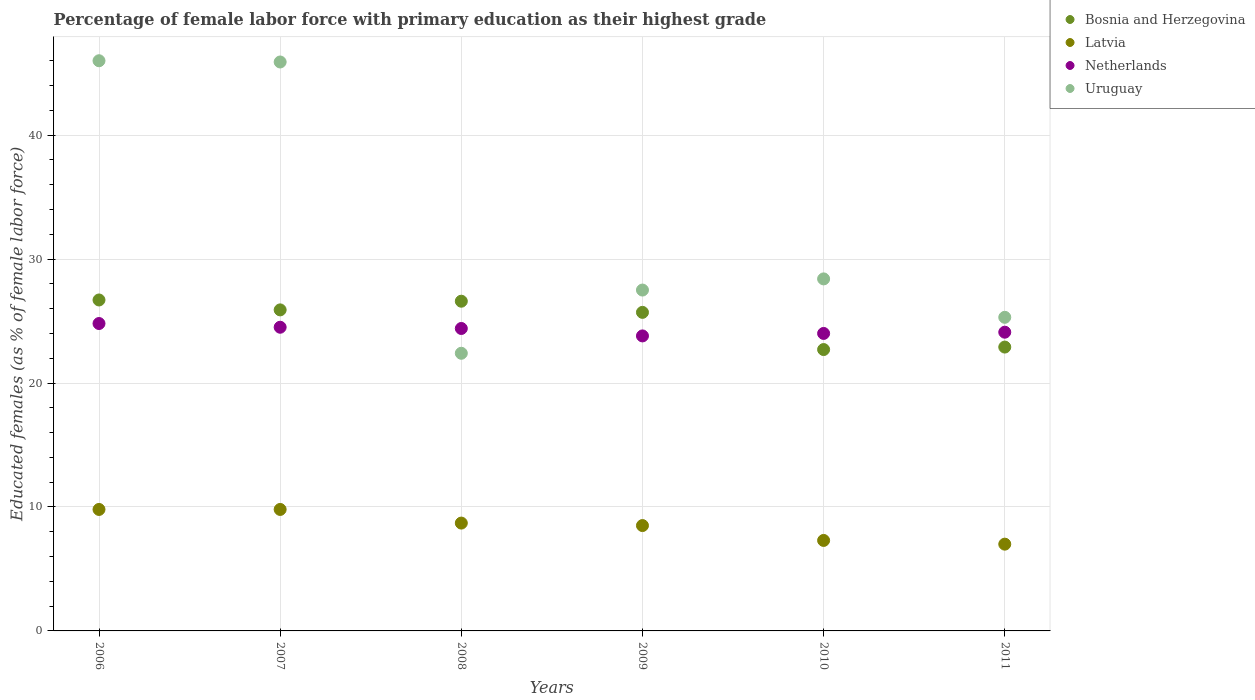Is the number of dotlines equal to the number of legend labels?
Keep it short and to the point. Yes. What is the percentage of female labor force with primary education in Uruguay in 2011?
Offer a very short reply. 25.3. In which year was the percentage of female labor force with primary education in Netherlands minimum?
Provide a succinct answer. 2009. What is the total percentage of female labor force with primary education in Netherlands in the graph?
Your response must be concise. 145.6. What is the difference between the percentage of female labor force with primary education in Latvia in 2006 and that in 2008?
Your response must be concise. 1.1. What is the difference between the percentage of female labor force with primary education in Bosnia and Herzegovina in 2006 and the percentage of female labor force with primary education in Latvia in 2010?
Make the answer very short. 19.4. What is the average percentage of female labor force with primary education in Netherlands per year?
Ensure brevity in your answer.  24.27. In the year 2010, what is the difference between the percentage of female labor force with primary education in Latvia and percentage of female labor force with primary education in Uruguay?
Keep it short and to the point. -21.1. In how many years, is the percentage of female labor force with primary education in Latvia greater than 40 %?
Your response must be concise. 0. What is the ratio of the percentage of female labor force with primary education in Latvia in 2006 to that in 2008?
Provide a succinct answer. 1.13. What is the difference between the highest and the second highest percentage of female labor force with primary education in Bosnia and Herzegovina?
Your answer should be very brief. 0.1. Is the percentage of female labor force with primary education in Uruguay strictly greater than the percentage of female labor force with primary education in Latvia over the years?
Your response must be concise. Yes. Does the graph contain any zero values?
Make the answer very short. No. What is the title of the graph?
Give a very brief answer. Percentage of female labor force with primary education as their highest grade. Does "Pacific island small states" appear as one of the legend labels in the graph?
Make the answer very short. No. What is the label or title of the X-axis?
Provide a short and direct response. Years. What is the label or title of the Y-axis?
Provide a short and direct response. Educated females (as % of female labor force). What is the Educated females (as % of female labor force) in Bosnia and Herzegovina in 2006?
Provide a short and direct response. 26.7. What is the Educated females (as % of female labor force) in Latvia in 2006?
Offer a terse response. 9.8. What is the Educated females (as % of female labor force) of Netherlands in 2006?
Ensure brevity in your answer.  24.8. What is the Educated females (as % of female labor force) of Bosnia and Herzegovina in 2007?
Ensure brevity in your answer.  25.9. What is the Educated females (as % of female labor force) in Latvia in 2007?
Offer a terse response. 9.8. What is the Educated females (as % of female labor force) in Netherlands in 2007?
Provide a short and direct response. 24.5. What is the Educated females (as % of female labor force) in Uruguay in 2007?
Your answer should be compact. 45.9. What is the Educated females (as % of female labor force) of Bosnia and Herzegovina in 2008?
Provide a short and direct response. 26.6. What is the Educated females (as % of female labor force) in Latvia in 2008?
Give a very brief answer. 8.7. What is the Educated females (as % of female labor force) in Netherlands in 2008?
Offer a very short reply. 24.4. What is the Educated females (as % of female labor force) of Uruguay in 2008?
Ensure brevity in your answer.  22.4. What is the Educated females (as % of female labor force) of Bosnia and Herzegovina in 2009?
Offer a very short reply. 25.7. What is the Educated females (as % of female labor force) in Latvia in 2009?
Your answer should be compact. 8.5. What is the Educated females (as % of female labor force) in Netherlands in 2009?
Your response must be concise. 23.8. What is the Educated females (as % of female labor force) in Bosnia and Herzegovina in 2010?
Offer a very short reply. 22.7. What is the Educated females (as % of female labor force) in Latvia in 2010?
Keep it short and to the point. 7.3. What is the Educated females (as % of female labor force) of Uruguay in 2010?
Ensure brevity in your answer.  28.4. What is the Educated females (as % of female labor force) in Bosnia and Herzegovina in 2011?
Offer a terse response. 22.9. What is the Educated females (as % of female labor force) of Latvia in 2011?
Offer a terse response. 7. What is the Educated females (as % of female labor force) in Netherlands in 2011?
Your response must be concise. 24.1. What is the Educated females (as % of female labor force) in Uruguay in 2011?
Offer a very short reply. 25.3. Across all years, what is the maximum Educated females (as % of female labor force) of Bosnia and Herzegovina?
Your answer should be very brief. 26.7. Across all years, what is the maximum Educated females (as % of female labor force) in Latvia?
Your answer should be very brief. 9.8. Across all years, what is the maximum Educated females (as % of female labor force) in Netherlands?
Provide a short and direct response. 24.8. Across all years, what is the maximum Educated females (as % of female labor force) in Uruguay?
Offer a terse response. 46. Across all years, what is the minimum Educated females (as % of female labor force) of Bosnia and Herzegovina?
Keep it short and to the point. 22.7. Across all years, what is the minimum Educated females (as % of female labor force) in Netherlands?
Offer a very short reply. 23.8. Across all years, what is the minimum Educated females (as % of female labor force) of Uruguay?
Make the answer very short. 22.4. What is the total Educated females (as % of female labor force) of Bosnia and Herzegovina in the graph?
Keep it short and to the point. 150.5. What is the total Educated females (as % of female labor force) in Latvia in the graph?
Your response must be concise. 51.1. What is the total Educated females (as % of female labor force) in Netherlands in the graph?
Provide a short and direct response. 145.6. What is the total Educated females (as % of female labor force) of Uruguay in the graph?
Ensure brevity in your answer.  195.5. What is the difference between the Educated females (as % of female labor force) in Netherlands in 2006 and that in 2007?
Your answer should be very brief. 0.3. What is the difference between the Educated females (as % of female labor force) in Uruguay in 2006 and that in 2007?
Keep it short and to the point. 0.1. What is the difference between the Educated females (as % of female labor force) in Uruguay in 2006 and that in 2008?
Your answer should be very brief. 23.6. What is the difference between the Educated females (as % of female labor force) in Bosnia and Herzegovina in 2006 and that in 2009?
Make the answer very short. 1. What is the difference between the Educated females (as % of female labor force) in Latvia in 2006 and that in 2009?
Keep it short and to the point. 1.3. What is the difference between the Educated females (as % of female labor force) of Uruguay in 2006 and that in 2009?
Your answer should be very brief. 18.5. What is the difference between the Educated females (as % of female labor force) of Latvia in 2006 and that in 2010?
Your answer should be compact. 2.5. What is the difference between the Educated females (as % of female labor force) in Uruguay in 2006 and that in 2010?
Make the answer very short. 17.6. What is the difference between the Educated females (as % of female labor force) in Uruguay in 2006 and that in 2011?
Provide a short and direct response. 20.7. What is the difference between the Educated females (as % of female labor force) of Bosnia and Herzegovina in 2007 and that in 2008?
Provide a succinct answer. -0.7. What is the difference between the Educated females (as % of female labor force) in Netherlands in 2007 and that in 2008?
Give a very brief answer. 0.1. What is the difference between the Educated females (as % of female labor force) in Netherlands in 2007 and that in 2009?
Your response must be concise. 0.7. What is the difference between the Educated females (as % of female labor force) in Uruguay in 2007 and that in 2009?
Your answer should be very brief. 18.4. What is the difference between the Educated females (as % of female labor force) in Latvia in 2007 and that in 2010?
Your response must be concise. 2.5. What is the difference between the Educated females (as % of female labor force) of Netherlands in 2007 and that in 2010?
Your answer should be compact. 0.5. What is the difference between the Educated females (as % of female labor force) of Bosnia and Herzegovina in 2007 and that in 2011?
Your answer should be compact. 3. What is the difference between the Educated females (as % of female labor force) of Netherlands in 2007 and that in 2011?
Provide a succinct answer. 0.4. What is the difference between the Educated females (as % of female labor force) in Uruguay in 2007 and that in 2011?
Your answer should be compact. 20.6. What is the difference between the Educated females (as % of female labor force) of Netherlands in 2008 and that in 2009?
Provide a short and direct response. 0.6. What is the difference between the Educated females (as % of female labor force) in Uruguay in 2008 and that in 2009?
Offer a very short reply. -5.1. What is the difference between the Educated females (as % of female labor force) in Latvia in 2008 and that in 2010?
Ensure brevity in your answer.  1.4. What is the difference between the Educated females (as % of female labor force) in Netherlands in 2008 and that in 2010?
Offer a terse response. 0.4. What is the difference between the Educated females (as % of female labor force) of Netherlands in 2009 and that in 2010?
Keep it short and to the point. -0.2. What is the difference between the Educated females (as % of female labor force) of Uruguay in 2009 and that in 2011?
Provide a succinct answer. 2.2. What is the difference between the Educated females (as % of female labor force) in Netherlands in 2010 and that in 2011?
Provide a succinct answer. -0.1. What is the difference between the Educated females (as % of female labor force) of Bosnia and Herzegovina in 2006 and the Educated females (as % of female labor force) of Uruguay in 2007?
Your response must be concise. -19.2. What is the difference between the Educated females (as % of female labor force) of Latvia in 2006 and the Educated females (as % of female labor force) of Netherlands in 2007?
Your response must be concise. -14.7. What is the difference between the Educated females (as % of female labor force) of Latvia in 2006 and the Educated females (as % of female labor force) of Uruguay in 2007?
Make the answer very short. -36.1. What is the difference between the Educated females (as % of female labor force) of Netherlands in 2006 and the Educated females (as % of female labor force) of Uruguay in 2007?
Provide a succinct answer. -21.1. What is the difference between the Educated females (as % of female labor force) in Bosnia and Herzegovina in 2006 and the Educated females (as % of female labor force) in Netherlands in 2008?
Offer a terse response. 2.3. What is the difference between the Educated females (as % of female labor force) in Bosnia and Herzegovina in 2006 and the Educated females (as % of female labor force) in Uruguay in 2008?
Provide a succinct answer. 4.3. What is the difference between the Educated females (as % of female labor force) in Latvia in 2006 and the Educated females (as % of female labor force) in Netherlands in 2008?
Make the answer very short. -14.6. What is the difference between the Educated females (as % of female labor force) of Netherlands in 2006 and the Educated females (as % of female labor force) of Uruguay in 2008?
Offer a very short reply. 2.4. What is the difference between the Educated females (as % of female labor force) of Bosnia and Herzegovina in 2006 and the Educated females (as % of female labor force) of Latvia in 2009?
Your answer should be compact. 18.2. What is the difference between the Educated females (as % of female labor force) of Bosnia and Herzegovina in 2006 and the Educated females (as % of female labor force) of Netherlands in 2009?
Offer a very short reply. 2.9. What is the difference between the Educated females (as % of female labor force) in Bosnia and Herzegovina in 2006 and the Educated females (as % of female labor force) in Uruguay in 2009?
Your response must be concise. -0.8. What is the difference between the Educated females (as % of female labor force) in Latvia in 2006 and the Educated females (as % of female labor force) in Netherlands in 2009?
Your response must be concise. -14. What is the difference between the Educated females (as % of female labor force) of Latvia in 2006 and the Educated females (as % of female labor force) of Uruguay in 2009?
Provide a succinct answer. -17.7. What is the difference between the Educated females (as % of female labor force) in Netherlands in 2006 and the Educated females (as % of female labor force) in Uruguay in 2009?
Provide a short and direct response. -2.7. What is the difference between the Educated females (as % of female labor force) in Bosnia and Herzegovina in 2006 and the Educated females (as % of female labor force) in Uruguay in 2010?
Offer a very short reply. -1.7. What is the difference between the Educated females (as % of female labor force) in Latvia in 2006 and the Educated females (as % of female labor force) in Uruguay in 2010?
Provide a succinct answer. -18.6. What is the difference between the Educated females (as % of female labor force) in Bosnia and Herzegovina in 2006 and the Educated females (as % of female labor force) in Latvia in 2011?
Your answer should be compact. 19.7. What is the difference between the Educated females (as % of female labor force) of Bosnia and Herzegovina in 2006 and the Educated females (as % of female labor force) of Netherlands in 2011?
Offer a very short reply. 2.6. What is the difference between the Educated females (as % of female labor force) of Bosnia and Herzegovina in 2006 and the Educated females (as % of female labor force) of Uruguay in 2011?
Keep it short and to the point. 1.4. What is the difference between the Educated females (as % of female labor force) of Latvia in 2006 and the Educated females (as % of female labor force) of Netherlands in 2011?
Make the answer very short. -14.3. What is the difference between the Educated females (as % of female labor force) of Latvia in 2006 and the Educated females (as % of female labor force) of Uruguay in 2011?
Keep it short and to the point. -15.5. What is the difference between the Educated females (as % of female labor force) in Bosnia and Herzegovina in 2007 and the Educated females (as % of female labor force) in Netherlands in 2008?
Ensure brevity in your answer.  1.5. What is the difference between the Educated females (as % of female labor force) in Latvia in 2007 and the Educated females (as % of female labor force) in Netherlands in 2008?
Your response must be concise. -14.6. What is the difference between the Educated females (as % of female labor force) in Latvia in 2007 and the Educated females (as % of female labor force) in Uruguay in 2008?
Keep it short and to the point. -12.6. What is the difference between the Educated females (as % of female labor force) of Bosnia and Herzegovina in 2007 and the Educated females (as % of female labor force) of Netherlands in 2009?
Keep it short and to the point. 2.1. What is the difference between the Educated females (as % of female labor force) of Latvia in 2007 and the Educated females (as % of female labor force) of Netherlands in 2009?
Your response must be concise. -14. What is the difference between the Educated females (as % of female labor force) in Latvia in 2007 and the Educated females (as % of female labor force) in Uruguay in 2009?
Ensure brevity in your answer.  -17.7. What is the difference between the Educated females (as % of female labor force) in Bosnia and Herzegovina in 2007 and the Educated females (as % of female labor force) in Netherlands in 2010?
Ensure brevity in your answer.  1.9. What is the difference between the Educated females (as % of female labor force) in Latvia in 2007 and the Educated females (as % of female labor force) in Netherlands in 2010?
Your answer should be very brief. -14.2. What is the difference between the Educated females (as % of female labor force) of Latvia in 2007 and the Educated females (as % of female labor force) of Uruguay in 2010?
Your answer should be compact. -18.6. What is the difference between the Educated females (as % of female labor force) in Netherlands in 2007 and the Educated females (as % of female labor force) in Uruguay in 2010?
Offer a very short reply. -3.9. What is the difference between the Educated females (as % of female labor force) of Bosnia and Herzegovina in 2007 and the Educated females (as % of female labor force) of Latvia in 2011?
Offer a terse response. 18.9. What is the difference between the Educated females (as % of female labor force) of Bosnia and Herzegovina in 2007 and the Educated females (as % of female labor force) of Netherlands in 2011?
Your response must be concise. 1.8. What is the difference between the Educated females (as % of female labor force) in Bosnia and Herzegovina in 2007 and the Educated females (as % of female labor force) in Uruguay in 2011?
Provide a succinct answer. 0.6. What is the difference between the Educated females (as % of female labor force) of Latvia in 2007 and the Educated females (as % of female labor force) of Netherlands in 2011?
Offer a very short reply. -14.3. What is the difference between the Educated females (as % of female labor force) of Latvia in 2007 and the Educated females (as % of female labor force) of Uruguay in 2011?
Provide a succinct answer. -15.5. What is the difference between the Educated females (as % of female labor force) in Netherlands in 2007 and the Educated females (as % of female labor force) in Uruguay in 2011?
Give a very brief answer. -0.8. What is the difference between the Educated females (as % of female labor force) in Bosnia and Herzegovina in 2008 and the Educated females (as % of female labor force) in Latvia in 2009?
Your response must be concise. 18.1. What is the difference between the Educated females (as % of female labor force) of Bosnia and Herzegovina in 2008 and the Educated females (as % of female labor force) of Netherlands in 2009?
Give a very brief answer. 2.8. What is the difference between the Educated females (as % of female labor force) of Bosnia and Herzegovina in 2008 and the Educated females (as % of female labor force) of Uruguay in 2009?
Make the answer very short. -0.9. What is the difference between the Educated females (as % of female labor force) in Latvia in 2008 and the Educated females (as % of female labor force) in Netherlands in 2009?
Offer a very short reply. -15.1. What is the difference between the Educated females (as % of female labor force) in Latvia in 2008 and the Educated females (as % of female labor force) in Uruguay in 2009?
Make the answer very short. -18.8. What is the difference between the Educated females (as % of female labor force) in Netherlands in 2008 and the Educated females (as % of female labor force) in Uruguay in 2009?
Your answer should be very brief. -3.1. What is the difference between the Educated females (as % of female labor force) in Bosnia and Herzegovina in 2008 and the Educated females (as % of female labor force) in Latvia in 2010?
Provide a short and direct response. 19.3. What is the difference between the Educated females (as % of female labor force) of Bosnia and Herzegovina in 2008 and the Educated females (as % of female labor force) of Netherlands in 2010?
Keep it short and to the point. 2.6. What is the difference between the Educated females (as % of female labor force) in Bosnia and Herzegovina in 2008 and the Educated females (as % of female labor force) in Uruguay in 2010?
Offer a very short reply. -1.8. What is the difference between the Educated females (as % of female labor force) in Latvia in 2008 and the Educated females (as % of female labor force) in Netherlands in 2010?
Your response must be concise. -15.3. What is the difference between the Educated females (as % of female labor force) in Latvia in 2008 and the Educated females (as % of female labor force) in Uruguay in 2010?
Provide a short and direct response. -19.7. What is the difference between the Educated females (as % of female labor force) in Bosnia and Herzegovina in 2008 and the Educated females (as % of female labor force) in Latvia in 2011?
Offer a terse response. 19.6. What is the difference between the Educated females (as % of female labor force) in Bosnia and Herzegovina in 2008 and the Educated females (as % of female labor force) in Netherlands in 2011?
Provide a short and direct response. 2.5. What is the difference between the Educated females (as % of female labor force) of Latvia in 2008 and the Educated females (as % of female labor force) of Netherlands in 2011?
Offer a terse response. -15.4. What is the difference between the Educated females (as % of female labor force) in Latvia in 2008 and the Educated females (as % of female labor force) in Uruguay in 2011?
Provide a short and direct response. -16.6. What is the difference between the Educated females (as % of female labor force) of Netherlands in 2008 and the Educated females (as % of female labor force) of Uruguay in 2011?
Provide a short and direct response. -0.9. What is the difference between the Educated females (as % of female labor force) in Bosnia and Herzegovina in 2009 and the Educated females (as % of female labor force) in Latvia in 2010?
Keep it short and to the point. 18.4. What is the difference between the Educated females (as % of female labor force) in Latvia in 2009 and the Educated females (as % of female labor force) in Netherlands in 2010?
Offer a very short reply. -15.5. What is the difference between the Educated females (as % of female labor force) of Latvia in 2009 and the Educated females (as % of female labor force) of Uruguay in 2010?
Provide a short and direct response. -19.9. What is the difference between the Educated females (as % of female labor force) in Bosnia and Herzegovina in 2009 and the Educated females (as % of female labor force) in Latvia in 2011?
Keep it short and to the point. 18.7. What is the difference between the Educated females (as % of female labor force) of Bosnia and Herzegovina in 2009 and the Educated females (as % of female labor force) of Uruguay in 2011?
Ensure brevity in your answer.  0.4. What is the difference between the Educated females (as % of female labor force) in Latvia in 2009 and the Educated females (as % of female labor force) in Netherlands in 2011?
Provide a succinct answer. -15.6. What is the difference between the Educated females (as % of female labor force) in Latvia in 2009 and the Educated females (as % of female labor force) in Uruguay in 2011?
Offer a terse response. -16.8. What is the difference between the Educated females (as % of female labor force) in Bosnia and Herzegovina in 2010 and the Educated females (as % of female labor force) in Uruguay in 2011?
Provide a short and direct response. -2.6. What is the difference between the Educated females (as % of female labor force) of Latvia in 2010 and the Educated females (as % of female labor force) of Netherlands in 2011?
Offer a terse response. -16.8. What is the difference between the Educated females (as % of female labor force) of Latvia in 2010 and the Educated females (as % of female labor force) of Uruguay in 2011?
Offer a very short reply. -18. What is the average Educated females (as % of female labor force) of Bosnia and Herzegovina per year?
Your response must be concise. 25.08. What is the average Educated females (as % of female labor force) of Latvia per year?
Offer a terse response. 8.52. What is the average Educated females (as % of female labor force) of Netherlands per year?
Ensure brevity in your answer.  24.27. What is the average Educated females (as % of female labor force) in Uruguay per year?
Your response must be concise. 32.58. In the year 2006, what is the difference between the Educated females (as % of female labor force) in Bosnia and Herzegovina and Educated females (as % of female labor force) in Uruguay?
Ensure brevity in your answer.  -19.3. In the year 2006, what is the difference between the Educated females (as % of female labor force) in Latvia and Educated females (as % of female labor force) in Netherlands?
Offer a very short reply. -15. In the year 2006, what is the difference between the Educated females (as % of female labor force) of Latvia and Educated females (as % of female labor force) of Uruguay?
Your answer should be very brief. -36.2. In the year 2006, what is the difference between the Educated females (as % of female labor force) of Netherlands and Educated females (as % of female labor force) of Uruguay?
Your response must be concise. -21.2. In the year 2007, what is the difference between the Educated females (as % of female labor force) in Bosnia and Herzegovina and Educated females (as % of female labor force) in Uruguay?
Ensure brevity in your answer.  -20. In the year 2007, what is the difference between the Educated females (as % of female labor force) in Latvia and Educated females (as % of female labor force) in Netherlands?
Provide a short and direct response. -14.7. In the year 2007, what is the difference between the Educated females (as % of female labor force) in Latvia and Educated females (as % of female labor force) in Uruguay?
Give a very brief answer. -36.1. In the year 2007, what is the difference between the Educated females (as % of female labor force) in Netherlands and Educated females (as % of female labor force) in Uruguay?
Offer a terse response. -21.4. In the year 2008, what is the difference between the Educated females (as % of female labor force) of Bosnia and Herzegovina and Educated females (as % of female labor force) of Latvia?
Your answer should be compact. 17.9. In the year 2008, what is the difference between the Educated females (as % of female labor force) in Latvia and Educated females (as % of female labor force) in Netherlands?
Your answer should be very brief. -15.7. In the year 2008, what is the difference between the Educated females (as % of female labor force) of Latvia and Educated females (as % of female labor force) of Uruguay?
Keep it short and to the point. -13.7. In the year 2009, what is the difference between the Educated females (as % of female labor force) of Bosnia and Herzegovina and Educated females (as % of female labor force) of Uruguay?
Give a very brief answer. -1.8. In the year 2009, what is the difference between the Educated females (as % of female labor force) of Latvia and Educated females (as % of female labor force) of Netherlands?
Your answer should be compact. -15.3. In the year 2010, what is the difference between the Educated females (as % of female labor force) of Bosnia and Herzegovina and Educated females (as % of female labor force) of Latvia?
Ensure brevity in your answer.  15.4. In the year 2010, what is the difference between the Educated females (as % of female labor force) in Bosnia and Herzegovina and Educated females (as % of female labor force) in Netherlands?
Keep it short and to the point. -1.3. In the year 2010, what is the difference between the Educated females (as % of female labor force) of Latvia and Educated females (as % of female labor force) of Netherlands?
Your answer should be very brief. -16.7. In the year 2010, what is the difference between the Educated females (as % of female labor force) in Latvia and Educated females (as % of female labor force) in Uruguay?
Your answer should be compact. -21.1. In the year 2011, what is the difference between the Educated females (as % of female labor force) in Bosnia and Herzegovina and Educated females (as % of female labor force) in Latvia?
Provide a short and direct response. 15.9. In the year 2011, what is the difference between the Educated females (as % of female labor force) of Bosnia and Herzegovina and Educated females (as % of female labor force) of Uruguay?
Give a very brief answer. -2.4. In the year 2011, what is the difference between the Educated females (as % of female labor force) in Latvia and Educated females (as % of female labor force) in Netherlands?
Your answer should be compact. -17.1. In the year 2011, what is the difference between the Educated females (as % of female labor force) in Latvia and Educated females (as % of female labor force) in Uruguay?
Your response must be concise. -18.3. In the year 2011, what is the difference between the Educated females (as % of female labor force) in Netherlands and Educated females (as % of female labor force) in Uruguay?
Your answer should be very brief. -1.2. What is the ratio of the Educated females (as % of female labor force) of Bosnia and Herzegovina in 2006 to that in 2007?
Provide a succinct answer. 1.03. What is the ratio of the Educated females (as % of female labor force) in Latvia in 2006 to that in 2007?
Offer a very short reply. 1. What is the ratio of the Educated females (as % of female labor force) in Netherlands in 2006 to that in 2007?
Provide a short and direct response. 1.01. What is the ratio of the Educated females (as % of female labor force) of Latvia in 2006 to that in 2008?
Keep it short and to the point. 1.13. What is the ratio of the Educated females (as % of female labor force) of Netherlands in 2006 to that in 2008?
Your response must be concise. 1.02. What is the ratio of the Educated females (as % of female labor force) in Uruguay in 2006 to that in 2008?
Offer a terse response. 2.05. What is the ratio of the Educated females (as % of female labor force) of Bosnia and Herzegovina in 2006 to that in 2009?
Make the answer very short. 1.04. What is the ratio of the Educated females (as % of female labor force) of Latvia in 2006 to that in 2009?
Offer a terse response. 1.15. What is the ratio of the Educated females (as % of female labor force) of Netherlands in 2006 to that in 2009?
Provide a short and direct response. 1.04. What is the ratio of the Educated females (as % of female labor force) of Uruguay in 2006 to that in 2009?
Your response must be concise. 1.67. What is the ratio of the Educated females (as % of female labor force) in Bosnia and Herzegovina in 2006 to that in 2010?
Ensure brevity in your answer.  1.18. What is the ratio of the Educated females (as % of female labor force) in Latvia in 2006 to that in 2010?
Your answer should be very brief. 1.34. What is the ratio of the Educated females (as % of female labor force) in Uruguay in 2006 to that in 2010?
Offer a terse response. 1.62. What is the ratio of the Educated females (as % of female labor force) in Bosnia and Herzegovina in 2006 to that in 2011?
Your answer should be very brief. 1.17. What is the ratio of the Educated females (as % of female labor force) of Latvia in 2006 to that in 2011?
Keep it short and to the point. 1.4. What is the ratio of the Educated females (as % of female labor force) in Uruguay in 2006 to that in 2011?
Your answer should be very brief. 1.82. What is the ratio of the Educated females (as % of female labor force) of Bosnia and Herzegovina in 2007 to that in 2008?
Make the answer very short. 0.97. What is the ratio of the Educated females (as % of female labor force) in Latvia in 2007 to that in 2008?
Your response must be concise. 1.13. What is the ratio of the Educated females (as % of female labor force) in Netherlands in 2007 to that in 2008?
Your response must be concise. 1. What is the ratio of the Educated females (as % of female labor force) in Uruguay in 2007 to that in 2008?
Your response must be concise. 2.05. What is the ratio of the Educated females (as % of female labor force) of Bosnia and Herzegovina in 2007 to that in 2009?
Offer a very short reply. 1.01. What is the ratio of the Educated females (as % of female labor force) in Latvia in 2007 to that in 2009?
Make the answer very short. 1.15. What is the ratio of the Educated females (as % of female labor force) in Netherlands in 2007 to that in 2009?
Keep it short and to the point. 1.03. What is the ratio of the Educated females (as % of female labor force) in Uruguay in 2007 to that in 2009?
Offer a very short reply. 1.67. What is the ratio of the Educated females (as % of female labor force) of Bosnia and Herzegovina in 2007 to that in 2010?
Keep it short and to the point. 1.14. What is the ratio of the Educated females (as % of female labor force) in Latvia in 2007 to that in 2010?
Provide a short and direct response. 1.34. What is the ratio of the Educated females (as % of female labor force) in Netherlands in 2007 to that in 2010?
Provide a short and direct response. 1.02. What is the ratio of the Educated females (as % of female labor force) in Uruguay in 2007 to that in 2010?
Keep it short and to the point. 1.62. What is the ratio of the Educated females (as % of female labor force) in Bosnia and Herzegovina in 2007 to that in 2011?
Ensure brevity in your answer.  1.13. What is the ratio of the Educated females (as % of female labor force) of Latvia in 2007 to that in 2011?
Provide a short and direct response. 1.4. What is the ratio of the Educated females (as % of female labor force) in Netherlands in 2007 to that in 2011?
Your answer should be compact. 1.02. What is the ratio of the Educated females (as % of female labor force) in Uruguay in 2007 to that in 2011?
Your response must be concise. 1.81. What is the ratio of the Educated females (as % of female labor force) of Bosnia and Herzegovina in 2008 to that in 2009?
Your response must be concise. 1.03. What is the ratio of the Educated females (as % of female labor force) in Latvia in 2008 to that in 2009?
Your response must be concise. 1.02. What is the ratio of the Educated females (as % of female labor force) of Netherlands in 2008 to that in 2009?
Your answer should be compact. 1.03. What is the ratio of the Educated females (as % of female labor force) of Uruguay in 2008 to that in 2009?
Offer a terse response. 0.81. What is the ratio of the Educated females (as % of female labor force) of Bosnia and Herzegovina in 2008 to that in 2010?
Offer a very short reply. 1.17. What is the ratio of the Educated females (as % of female labor force) in Latvia in 2008 to that in 2010?
Your answer should be compact. 1.19. What is the ratio of the Educated females (as % of female labor force) of Netherlands in 2008 to that in 2010?
Make the answer very short. 1.02. What is the ratio of the Educated females (as % of female labor force) in Uruguay in 2008 to that in 2010?
Your response must be concise. 0.79. What is the ratio of the Educated females (as % of female labor force) of Bosnia and Herzegovina in 2008 to that in 2011?
Ensure brevity in your answer.  1.16. What is the ratio of the Educated females (as % of female labor force) in Latvia in 2008 to that in 2011?
Make the answer very short. 1.24. What is the ratio of the Educated females (as % of female labor force) in Netherlands in 2008 to that in 2011?
Give a very brief answer. 1.01. What is the ratio of the Educated females (as % of female labor force) of Uruguay in 2008 to that in 2011?
Make the answer very short. 0.89. What is the ratio of the Educated females (as % of female labor force) in Bosnia and Herzegovina in 2009 to that in 2010?
Offer a very short reply. 1.13. What is the ratio of the Educated females (as % of female labor force) of Latvia in 2009 to that in 2010?
Your answer should be compact. 1.16. What is the ratio of the Educated females (as % of female labor force) of Netherlands in 2009 to that in 2010?
Make the answer very short. 0.99. What is the ratio of the Educated females (as % of female labor force) of Uruguay in 2009 to that in 2010?
Offer a terse response. 0.97. What is the ratio of the Educated females (as % of female labor force) of Bosnia and Herzegovina in 2009 to that in 2011?
Ensure brevity in your answer.  1.12. What is the ratio of the Educated females (as % of female labor force) of Latvia in 2009 to that in 2011?
Your response must be concise. 1.21. What is the ratio of the Educated females (as % of female labor force) of Netherlands in 2009 to that in 2011?
Ensure brevity in your answer.  0.99. What is the ratio of the Educated females (as % of female labor force) in Uruguay in 2009 to that in 2011?
Keep it short and to the point. 1.09. What is the ratio of the Educated females (as % of female labor force) in Latvia in 2010 to that in 2011?
Provide a succinct answer. 1.04. What is the ratio of the Educated females (as % of female labor force) in Uruguay in 2010 to that in 2011?
Your answer should be compact. 1.12. What is the difference between the highest and the second highest Educated females (as % of female labor force) in Netherlands?
Ensure brevity in your answer.  0.3. What is the difference between the highest and the lowest Educated females (as % of female labor force) in Latvia?
Keep it short and to the point. 2.8. What is the difference between the highest and the lowest Educated females (as % of female labor force) in Netherlands?
Your answer should be very brief. 1. What is the difference between the highest and the lowest Educated females (as % of female labor force) of Uruguay?
Ensure brevity in your answer.  23.6. 